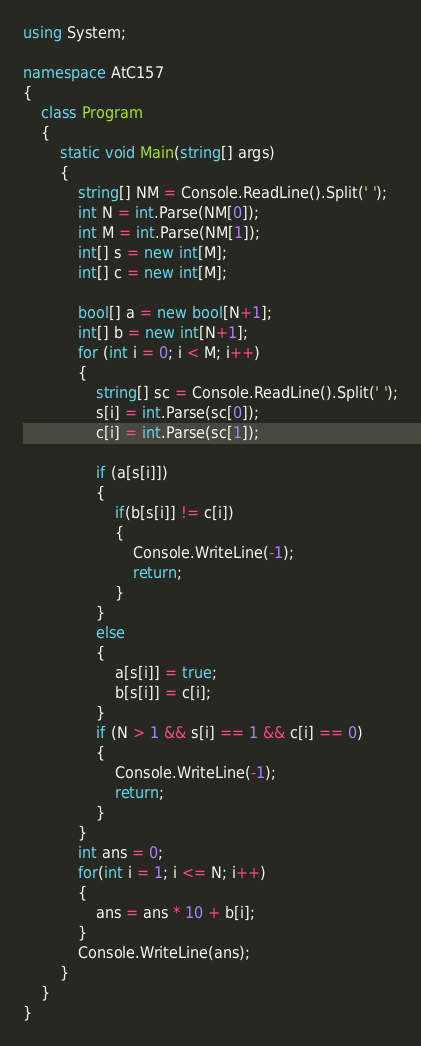Convert code to text. <code><loc_0><loc_0><loc_500><loc_500><_C#_>using System;

namespace AtC157
{
    class Program
    {
        static void Main(string[] args)
        {
            string[] NM = Console.ReadLine().Split(' ');
            int N = int.Parse(NM[0]);
            int M = int.Parse(NM[1]);
            int[] s = new int[M];
            int[] c = new int[M];

            bool[] a = new bool[N+1];
            int[] b = new int[N+1];
            for (int i = 0; i < M; i++)
            {
                string[] sc = Console.ReadLine().Split(' ');
                s[i] = int.Parse(sc[0]);
                c[i] = int.Parse(sc[1]);

                if (a[s[i]])
                {
                    if(b[s[i]] != c[i])
                    {
                        Console.WriteLine(-1);
                        return;
                    }
                }
                else
                {
                    a[s[i]] = true;
                    b[s[i]] = c[i];
                }
                if (N > 1 && s[i] == 1 && c[i] == 0)
                {
                    Console.WriteLine(-1);
                    return;
                }
            }
            int ans = 0;
            for(int i = 1; i <= N; i++)
            {
                ans = ans * 10 + b[i];
            }
            Console.WriteLine(ans);
        }
    }
}
</code> 